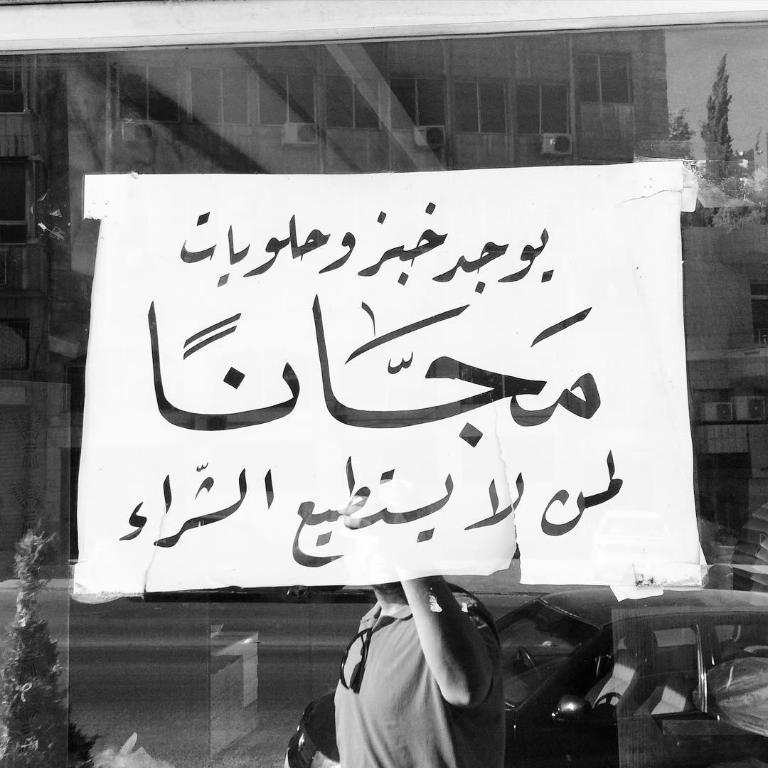What is on the glass surface in the image? There is a poster on a glass surface in the image. Can you describe what is visible through the glass? A person is visible through the glass in the image. What can be seen on the road in the image? There is a car on the road in the image. What type of vegetation is present in the image? There is a plant in the image, and trees are visible as well. What type of structure is in the image? There is a building in the image. What part of the natural environment is visible in the image? The sky is visible in the image. What is the purpose of the addition in the image? There is no mention of an addition in the image; the facts provided do not reference any such structure. 